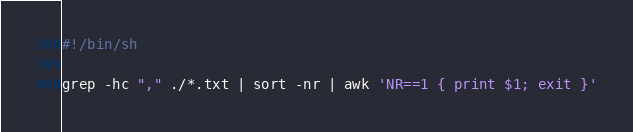Convert code to text. <code><loc_0><loc_0><loc_500><loc_500><_Bash_>#!/bin/sh

grep -hc "," ./*.txt | sort -nr | awk 'NR==1 { print $1; exit }'
</code> 